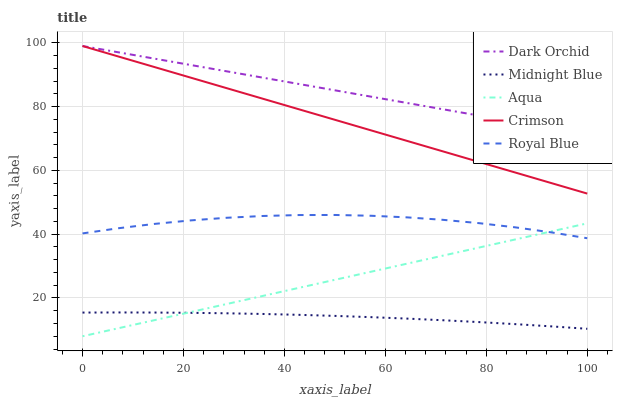Does Midnight Blue have the minimum area under the curve?
Answer yes or no. Yes. Does Dark Orchid have the maximum area under the curve?
Answer yes or no. Yes. Does Royal Blue have the minimum area under the curve?
Answer yes or no. No. Does Royal Blue have the maximum area under the curve?
Answer yes or no. No. Is Aqua the smoothest?
Answer yes or no. Yes. Is Royal Blue the roughest?
Answer yes or no. Yes. Is Royal Blue the smoothest?
Answer yes or no. No. Is Aqua the roughest?
Answer yes or no. No. Does Aqua have the lowest value?
Answer yes or no. Yes. Does Royal Blue have the lowest value?
Answer yes or no. No. Does Dark Orchid have the highest value?
Answer yes or no. Yes. Does Royal Blue have the highest value?
Answer yes or no. No. Is Midnight Blue less than Crimson?
Answer yes or no. Yes. Is Crimson greater than Aqua?
Answer yes or no. Yes. Does Aqua intersect Midnight Blue?
Answer yes or no. Yes. Is Aqua less than Midnight Blue?
Answer yes or no. No. Is Aqua greater than Midnight Blue?
Answer yes or no. No. Does Midnight Blue intersect Crimson?
Answer yes or no. No. 